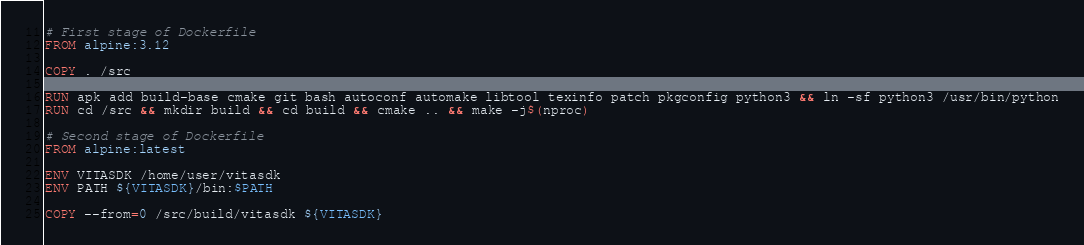<code> <loc_0><loc_0><loc_500><loc_500><_Dockerfile_># First stage of Dockerfile
FROM alpine:3.12

COPY . /src

RUN apk add build-base cmake git bash autoconf automake libtool texinfo patch pkgconfig python3 && ln -sf python3 /usr/bin/python
RUN cd /src && mkdir build && cd build && cmake .. && make -j$(nproc)

# Second stage of Dockerfile
FROM alpine:latest  

ENV VITASDK /home/user/vitasdk
ENV PATH ${VITASDK}/bin:$PATH

COPY --from=0 /src/build/vitasdk ${VITASDK}
</code> 